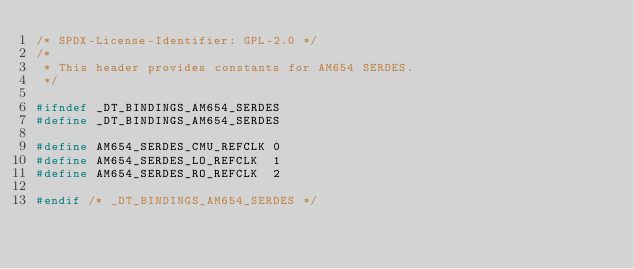<code> <loc_0><loc_0><loc_500><loc_500><_C_>/* SPDX-License-Identifier: GPL-2.0 */
/*
 * This header provides constants for AM654 SERDES.
 */

#ifndef _DT_BINDINGS_AM654_SERDES
#define _DT_BINDINGS_AM654_SERDES

#define AM654_SERDES_CMU_REFCLK	0
#define AM654_SERDES_LO_REFCLK	1
#define AM654_SERDES_RO_REFCLK	2

#endif /* _DT_BINDINGS_AM654_SERDES */
</code> 